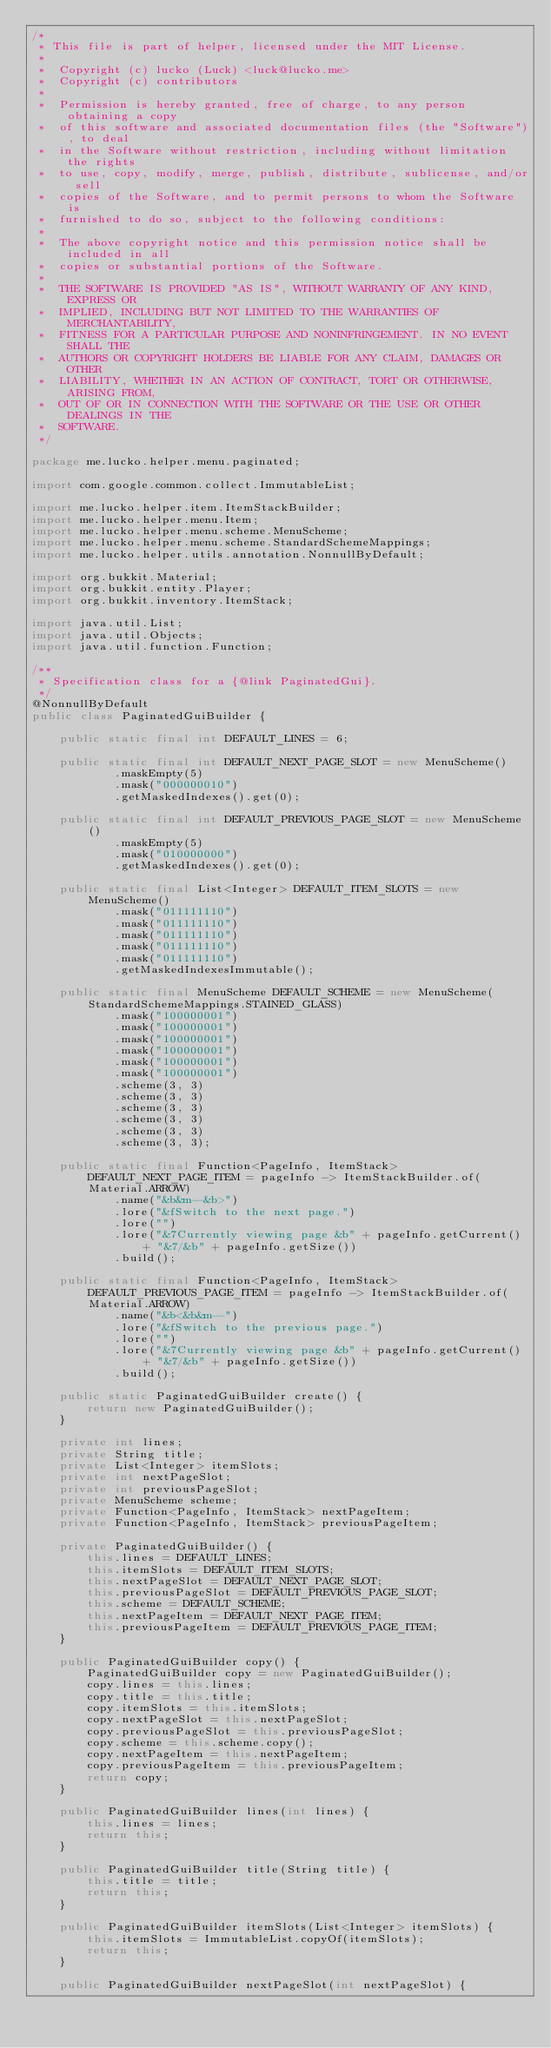<code> <loc_0><loc_0><loc_500><loc_500><_Java_>/*
 * This file is part of helper, licensed under the MIT License.
 *
 *  Copyright (c) lucko (Luck) <luck@lucko.me>
 *  Copyright (c) contributors
 *
 *  Permission is hereby granted, free of charge, to any person obtaining a copy
 *  of this software and associated documentation files (the "Software"), to deal
 *  in the Software without restriction, including without limitation the rights
 *  to use, copy, modify, merge, publish, distribute, sublicense, and/or sell
 *  copies of the Software, and to permit persons to whom the Software is
 *  furnished to do so, subject to the following conditions:
 *
 *  The above copyright notice and this permission notice shall be included in all
 *  copies or substantial portions of the Software.
 *
 *  THE SOFTWARE IS PROVIDED "AS IS", WITHOUT WARRANTY OF ANY KIND, EXPRESS OR
 *  IMPLIED, INCLUDING BUT NOT LIMITED TO THE WARRANTIES OF MERCHANTABILITY,
 *  FITNESS FOR A PARTICULAR PURPOSE AND NONINFRINGEMENT. IN NO EVENT SHALL THE
 *  AUTHORS OR COPYRIGHT HOLDERS BE LIABLE FOR ANY CLAIM, DAMAGES OR OTHER
 *  LIABILITY, WHETHER IN AN ACTION OF CONTRACT, TORT OR OTHERWISE, ARISING FROM,
 *  OUT OF OR IN CONNECTION WITH THE SOFTWARE OR THE USE OR OTHER DEALINGS IN THE
 *  SOFTWARE.
 */

package me.lucko.helper.menu.paginated;

import com.google.common.collect.ImmutableList;

import me.lucko.helper.item.ItemStackBuilder;
import me.lucko.helper.menu.Item;
import me.lucko.helper.menu.scheme.MenuScheme;
import me.lucko.helper.menu.scheme.StandardSchemeMappings;
import me.lucko.helper.utils.annotation.NonnullByDefault;

import org.bukkit.Material;
import org.bukkit.entity.Player;
import org.bukkit.inventory.ItemStack;

import java.util.List;
import java.util.Objects;
import java.util.function.Function;

/**
 * Specification class for a {@link PaginatedGui}.
 */
@NonnullByDefault
public class PaginatedGuiBuilder {

    public static final int DEFAULT_LINES = 6;

    public static final int DEFAULT_NEXT_PAGE_SLOT = new MenuScheme()
            .maskEmpty(5)
            .mask("000000010")
            .getMaskedIndexes().get(0);

    public static final int DEFAULT_PREVIOUS_PAGE_SLOT = new MenuScheme()
            .maskEmpty(5)
            .mask("010000000")
            .getMaskedIndexes().get(0);

    public static final List<Integer> DEFAULT_ITEM_SLOTS = new MenuScheme()
            .mask("011111110")
            .mask("011111110")
            .mask("011111110")
            .mask("011111110")
            .mask("011111110")
            .getMaskedIndexesImmutable();

    public static final MenuScheme DEFAULT_SCHEME = new MenuScheme(StandardSchemeMappings.STAINED_GLASS)
            .mask("100000001")
            .mask("100000001")
            .mask("100000001")
            .mask("100000001")
            .mask("100000001")
            .mask("100000001")
            .scheme(3, 3)
            .scheme(3, 3)
            .scheme(3, 3)
            .scheme(3, 3)
            .scheme(3, 3)
            .scheme(3, 3);

    public static final Function<PageInfo, ItemStack> DEFAULT_NEXT_PAGE_ITEM = pageInfo -> ItemStackBuilder.of(Material.ARROW)
            .name("&b&m--&b>")
            .lore("&fSwitch to the next page.")
            .lore("")
            .lore("&7Currently viewing page &b" + pageInfo.getCurrent() + "&7/&b" + pageInfo.getSize())
            .build();

    public static final Function<PageInfo, ItemStack> DEFAULT_PREVIOUS_PAGE_ITEM = pageInfo -> ItemStackBuilder.of(Material.ARROW)
            .name("&b<&b&m--")
            .lore("&fSwitch to the previous page.")
            .lore("")
            .lore("&7Currently viewing page &b" + pageInfo.getCurrent() + "&7/&b" + pageInfo.getSize())
            .build();

    public static PaginatedGuiBuilder create() {
        return new PaginatedGuiBuilder();
    }

    private int lines;
    private String title;
    private List<Integer> itemSlots;
    private int nextPageSlot;
    private int previousPageSlot;
    private MenuScheme scheme;
    private Function<PageInfo, ItemStack> nextPageItem;
    private Function<PageInfo, ItemStack> previousPageItem;

    private PaginatedGuiBuilder() {
        this.lines = DEFAULT_LINES;
        this.itemSlots = DEFAULT_ITEM_SLOTS;
        this.nextPageSlot = DEFAULT_NEXT_PAGE_SLOT;
        this.previousPageSlot = DEFAULT_PREVIOUS_PAGE_SLOT;
        this.scheme = DEFAULT_SCHEME;
        this.nextPageItem = DEFAULT_NEXT_PAGE_ITEM;
        this.previousPageItem = DEFAULT_PREVIOUS_PAGE_ITEM;
    }

    public PaginatedGuiBuilder copy() {
        PaginatedGuiBuilder copy = new PaginatedGuiBuilder();
        copy.lines = this.lines;
        copy.title = this.title;
        copy.itemSlots = this.itemSlots;
        copy.nextPageSlot = this.nextPageSlot;
        copy.previousPageSlot = this.previousPageSlot;
        copy.scheme = this.scheme.copy();
        copy.nextPageItem = this.nextPageItem;
        copy.previousPageItem = this.previousPageItem;
        return copy;
    }

    public PaginatedGuiBuilder lines(int lines) {
        this.lines = lines;
        return this;
    }

    public PaginatedGuiBuilder title(String title) {
        this.title = title;
        return this;
    }

    public PaginatedGuiBuilder itemSlots(List<Integer> itemSlots) {
        this.itemSlots = ImmutableList.copyOf(itemSlots);
        return this;
    }

    public PaginatedGuiBuilder nextPageSlot(int nextPageSlot) {</code> 